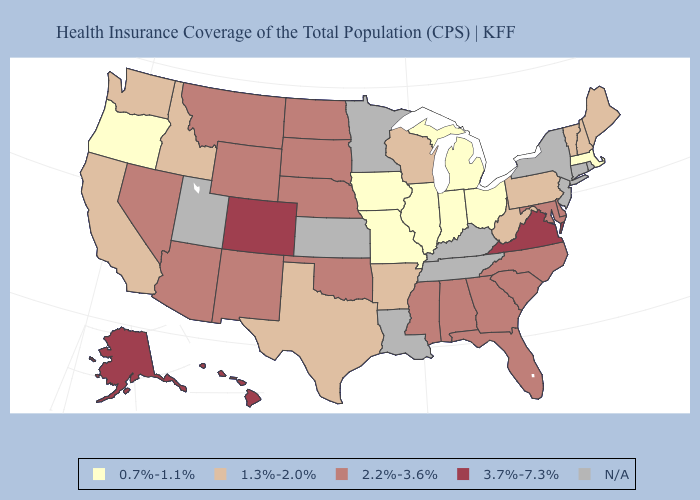Among the states that border Tennessee , does Missouri have the lowest value?
Be succinct. Yes. Name the states that have a value in the range 0.7%-1.1%?
Quick response, please. Illinois, Indiana, Iowa, Massachusetts, Michigan, Missouri, Ohio, Oregon. Does New Hampshire have the lowest value in the Northeast?
Give a very brief answer. No. What is the value of Indiana?
Keep it brief. 0.7%-1.1%. Does the map have missing data?
Write a very short answer. Yes. Name the states that have a value in the range 1.3%-2.0%?
Short answer required. Arkansas, California, Idaho, Maine, New Hampshire, Pennsylvania, Texas, Vermont, Washington, West Virginia, Wisconsin. Name the states that have a value in the range 0.7%-1.1%?
Be succinct. Illinois, Indiana, Iowa, Massachusetts, Michigan, Missouri, Ohio, Oregon. Name the states that have a value in the range 2.2%-3.6%?
Short answer required. Alabama, Arizona, Delaware, Florida, Georgia, Maryland, Mississippi, Montana, Nebraska, Nevada, New Mexico, North Carolina, North Dakota, Oklahoma, South Carolina, South Dakota, Wyoming. What is the value of Alaska?
Keep it brief. 3.7%-7.3%. Does the first symbol in the legend represent the smallest category?
Answer briefly. Yes. What is the highest value in states that border Tennessee?
Keep it brief. 3.7%-7.3%. What is the lowest value in the West?
Keep it brief. 0.7%-1.1%. Name the states that have a value in the range 1.3%-2.0%?
Answer briefly. Arkansas, California, Idaho, Maine, New Hampshire, Pennsylvania, Texas, Vermont, Washington, West Virginia, Wisconsin. 